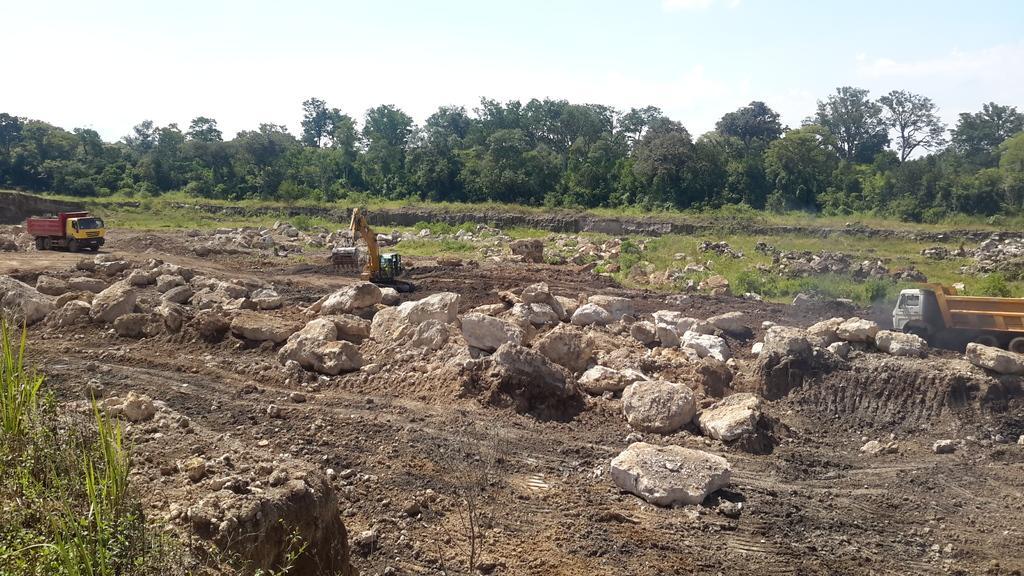Could you give a brief overview of what you see in this image? On the left there is a man who is riding a truck. In the center we can see the bulldozer. On the right we can see another truck and smoke is coming from the exhaust pipe. At the bottom we can see many stones. In background we can see a trees, plants and grass. At the top we can see sky and clouds. 